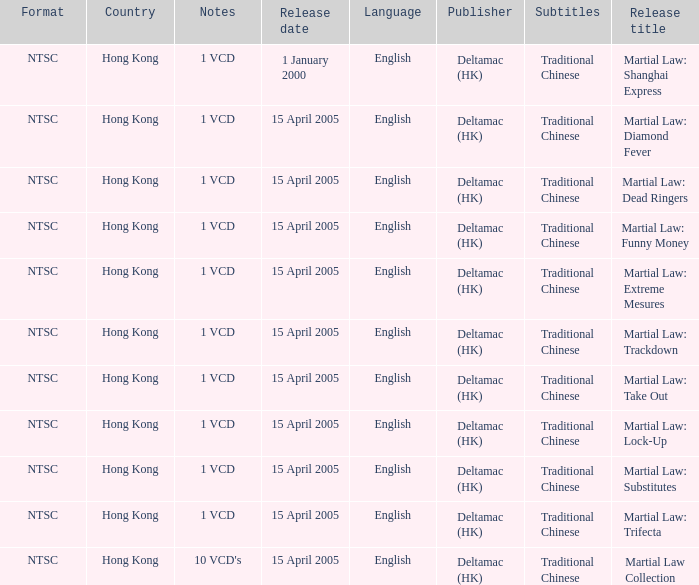Who was the publisher of Martial Law: Dead Ringers? Deltamac (HK). 